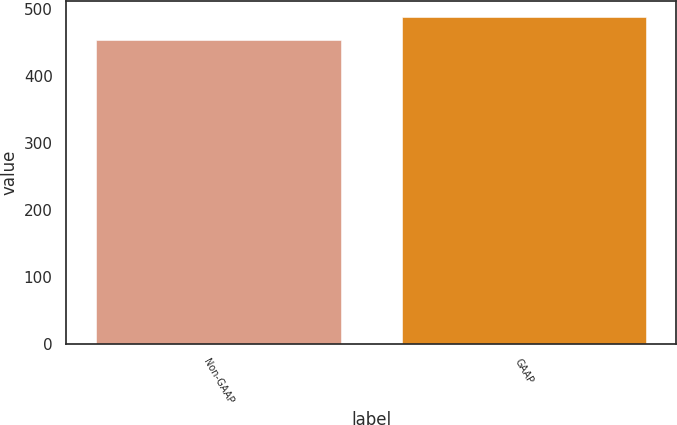Convert chart to OTSL. <chart><loc_0><loc_0><loc_500><loc_500><bar_chart><fcel>Non-GAAP<fcel>GAAP<nl><fcel>453<fcel>487<nl></chart> 